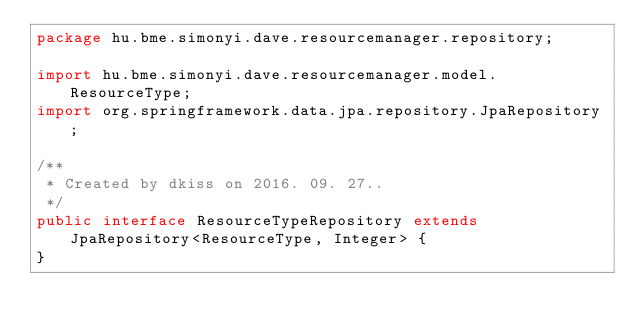Convert code to text. <code><loc_0><loc_0><loc_500><loc_500><_Java_>package hu.bme.simonyi.dave.resourcemanager.repository;

import hu.bme.simonyi.dave.resourcemanager.model.ResourceType;
import org.springframework.data.jpa.repository.JpaRepository;

/**
 * Created by dkiss on 2016. 09. 27..
 */
public interface ResourceTypeRepository extends JpaRepository<ResourceType, Integer> {
}
</code> 